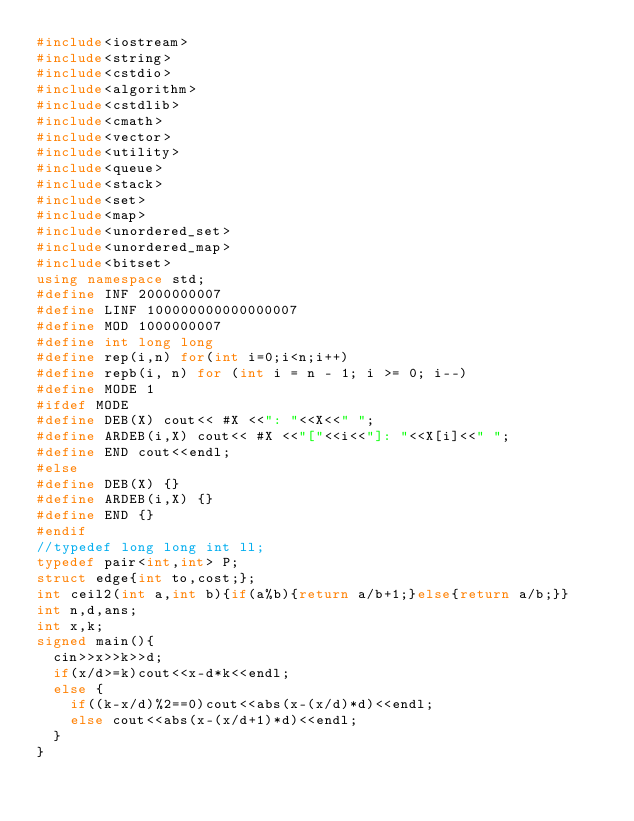<code> <loc_0><loc_0><loc_500><loc_500><_C++_>#include<iostream>
#include<string>
#include<cstdio>
#include<algorithm>
#include<cstdlib>
#include<cmath>
#include<vector>
#include<utility>
#include<queue>
#include<stack>
#include<set>
#include<map>
#include<unordered_set>
#include<unordered_map>
#include<bitset>
using namespace std;
#define INF 2000000007
#define LINF 100000000000000007
#define MOD 1000000007
#define int long long
#define rep(i,n) for(int i=0;i<n;i++)
#define repb(i, n) for (int i = n - 1; i >= 0; i--)
#define MODE 1
#ifdef MODE
#define DEB(X) cout<< #X <<": "<<X<<" ";
#define ARDEB(i,X) cout<< #X <<"["<<i<<"]: "<<X[i]<<" ";
#define END cout<<endl;
#else
#define DEB(X) {}
#define ARDEB(i,X) {}
#define END {}
#endif
//typedef long long int ll;
typedef pair<int,int> P;
struct edge{int to,cost;};
int ceil2(int a,int b){if(a%b){return a/b+1;}else{return a/b;}}
int n,d,ans;
int x,k;
signed main(){
	cin>>x>>k>>d;
	if(x/d>=k)cout<<x-d*k<<endl;
	else {
		if((k-x/d)%2==0)cout<<abs(x-(x/d)*d)<<endl;
		else cout<<abs(x-(x/d+1)*d)<<endl;
	}
}</code> 